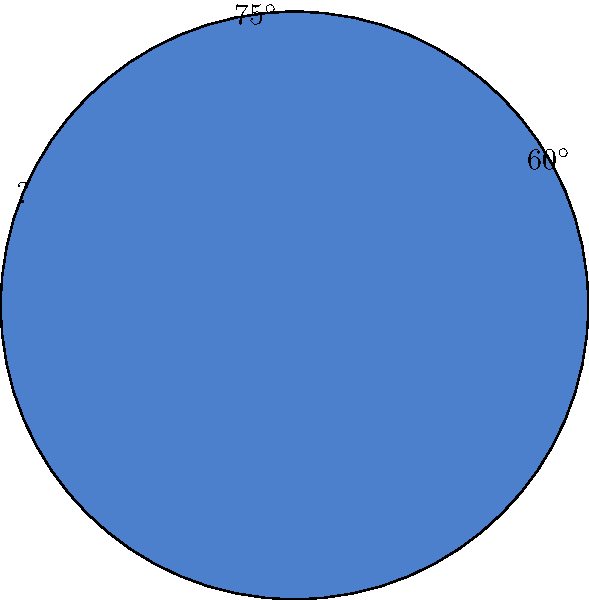As a Python programmer working on a data visualization project using Apache POI, you need to create a pie chart representing the angles of a triangle. Two angles are given: $60^\circ$ and $75^\circ$. Write a Python function that calculates the missing angle and returns it as a float. How would you implement this function, and what would be the return value for the given angles? To solve this problem, we can follow these steps:

1. Recall that the sum of angles in a triangle is always 180°.

2. We can represent this as an equation:
   $$ 60^\circ + 75^\circ + x = 180^\circ $$
   where $x$ is the missing angle we need to find.

3. To solve for $x$, we can subtract the known angles from 180°:
   $$ x = 180^\circ - (60^\circ + 75^\circ) = 180^\circ - 135^\circ = 45^\circ $$

4. To implement this as a Python function, we can use:

   ```python
   def calculate_missing_angle(angle1, angle2):
       return 180 - (angle1 + angle2)
   ```

5. To call this function with the given angles and return a float:

   ```python
   result = calculate_missing_angle(60, 75)
   print(f"The missing angle is: {result}")
   ```

This function will return 45.0, which is the missing angle in the triangle.
Answer: 45.0 